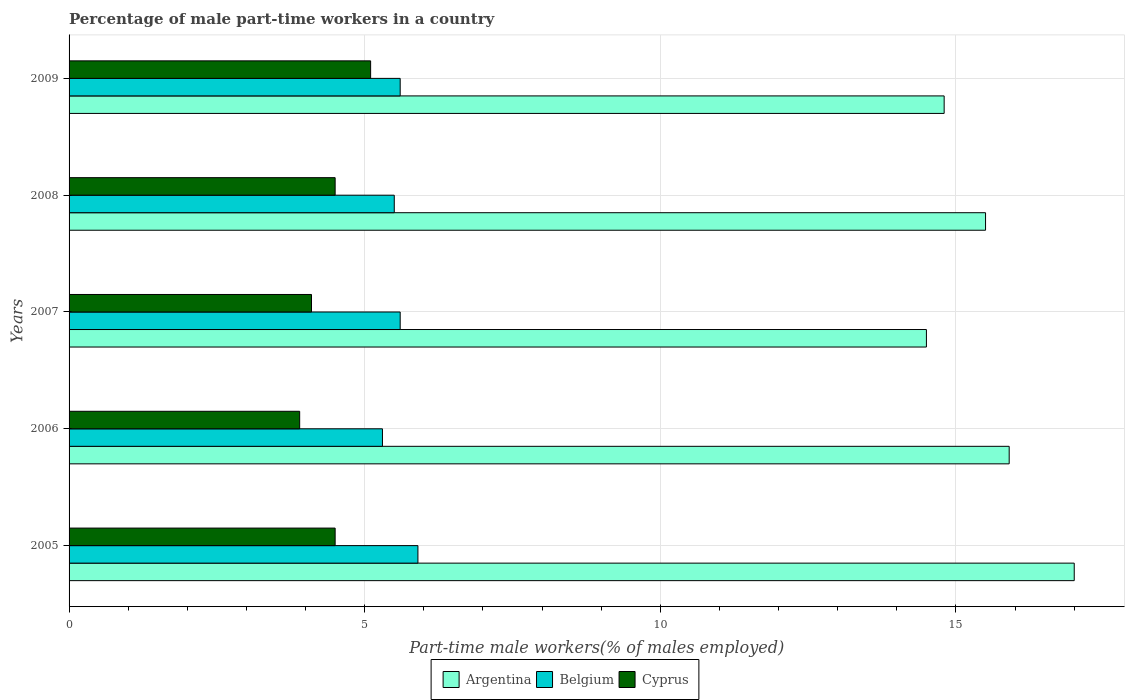How many groups of bars are there?
Keep it short and to the point. 5. Are the number of bars per tick equal to the number of legend labels?
Give a very brief answer. Yes. Are the number of bars on each tick of the Y-axis equal?
Provide a short and direct response. Yes. How many bars are there on the 1st tick from the bottom?
Your response must be concise. 3. What is the label of the 4th group of bars from the top?
Keep it short and to the point. 2006. In how many cases, is the number of bars for a given year not equal to the number of legend labels?
Your response must be concise. 0. What is the percentage of male part-time workers in Belgium in 2008?
Offer a terse response. 5.5. Across all years, what is the maximum percentage of male part-time workers in Belgium?
Provide a short and direct response. 5.9. Across all years, what is the minimum percentage of male part-time workers in Cyprus?
Keep it short and to the point. 3.9. What is the total percentage of male part-time workers in Belgium in the graph?
Your answer should be very brief. 27.9. What is the difference between the percentage of male part-time workers in Belgium in 2006 and that in 2008?
Make the answer very short. -0.2. What is the difference between the percentage of male part-time workers in Cyprus in 2006 and the percentage of male part-time workers in Belgium in 2008?
Your answer should be compact. -1.6. What is the average percentage of male part-time workers in Cyprus per year?
Provide a succinct answer. 4.42. In the year 2005, what is the difference between the percentage of male part-time workers in Belgium and percentage of male part-time workers in Argentina?
Your answer should be compact. -11.1. In how many years, is the percentage of male part-time workers in Argentina greater than 4 %?
Give a very brief answer. 5. What is the ratio of the percentage of male part-time workers in Belgium in 2006 to that in 2008?
Your response must be concise. 0.96. Is the difference between the percentage of male part-time workers in Belgium in 2008 and 2009 greater than the difference between the percentage of male part-time workers in Argentina in 2008 and 2009?
Ensure brevity in your answer.  No. What is the difference between the highest and the second highest percentage of male part-time workers in Cyprus?
Provide a succinct answer. 0.6. What is the difference between the highest and the lowest percentage of male part-time workers in Belgium?
Ensure brevity in your answer.  0.6. Is the sum of the percentage of male part-time workers in Cyprus in 2006 and 2008 greater than the maximum percentage of male part-time workers in Argentina across all years?
Offer a very short reply. No. What does the 3rd bar from the top in 2007 represents?
Offer a very short reply. Argentina. What does the 2nd bar from the bottom in 2005 represents?
Offer a terse response. Belgium. Is it the case that in every year, the sum of the percentage of male part-time workers in Belgium and percentage of male part-time workers in Argentina is greater than the percentage of male part-time workers in Cyprus?
Provide a succinct answer. Yes. How many bars are there?
Keep it short and to the point. 15. Are all the bars in the graph horizontal?
Give a very brief answer. Yes. Are the values on the major ticks of X-axis written in scientific E-notation?
Keep it short and to the point. No. Does the graph contain grids?
Provide a short and direct response. Yes. How many legend labels are there?
Provide a short and direct response. 3. What is the title of the graph?
Your answer should be compact. Percentage of male part-time workers in a country. Does "Syrian Arab Republic" appear as one of the legend labels in the graph?
Make the answer very short. No. What is the label or title of the X-axis?
Offer a very short reply. Part-time male workers(% of males employed). What is the label or title of the Y-axis?
Provide a short and direct response. Years. What is the Part-time male workers(% of males employed) in Argentina in 2005?
Ensure brevity in your answer.  17. What is the Part-time male workers(% of males employed) of Belgium in 2005?
Give a very brief answer. 5.9. What is the Part-time male workers(% of males employed) of Argentina in 2006?
Ensure brevity in your answer.  15.9. What is the Part-time male workers(% of males employed) of Belgium in 2006?
Your answer should be compact. 5.3. What is the Part-time male workers(% of males employed) in Cyprus in 2006?
Keep it short and to the point. 3.9. What is the Part-time male workers(% of males employed) of Argentina in 2007?
Provide a short and direct response. 14.5. What is the Part-time male workers(% of males employed) in Belgium in 2007?
Keep it short and to the point. 5.6. What is the Part-time male workers(% of males employed) of Cyprus in 2007?
Your response must be concise. 4.1. What is the Part-time male workers(% of males employed) in Argentina in 2009?
Offer a very short reply. 14.8. What is the Part-time male workers(% of males employed) of Belgium in 2009?
Provide a short and direct response. 5.6. What is the Part-time male workers(% of males employed) in Cyprus in 2009?
Your answer should be very brief. 5.1. Across all years, what is the maximum Part-time male workers(% of males employed) in Argentina?
Your answer should be compact. 17. Across all years, what is the maximum Part-time male workers(% of males employed) in Belgium?
Your answer should be compact. 5.9. Across all years, what is the maximum Part-time male workers(% of males employed) in Cyprus?
Ensure brevity in your answer.  5.1. Across all years, what is the minimum Part-time male workers(% of males employed) in Belgium?
Offer a terse response. 5.3. Across all years, what is the minimum Part-time male workers(% of males employed) in Cyprus?
Your answer should be very brief. 3.9. What is the total Part-time male workers(% of males employed) of Argentina in the graph?
Ensure brevity in your answer.  77.7. What is the total Part-time male workers(% of males employed) in Belgium in the graph?
Your answer should be very brief. 27.9. What is the total Part-time male workers(% of males employed) of Cyprus in the graph?
Offer a terse response. 22.1. What is the difference between the Part-time male workers(% of males employed) in Belgium in 2005 and that in 2007?
Offer a terse response. 0.3. What is the difference between the Part-time male workers(% of males employed) in Cyprus in 2005 and that in 2007?
Offer a very short reply. 0.4. What is the difference between the Part-time male workers(% of males employed) in Cyprus in 2005 and that in 2008?
Your response must be concise. 0. What is the difference between the Part-time male workers(% of males employed) in Cyprus in 2005 and that in 2009?
Keep it short and to the point. -0.6. What is the difference between the Part-time male workers(% of males employed) in Argentina in 2006 and that in 2007?
Your response must be concise. 1.4. What is the difference between the Part-time male workers(% of males employed) in Belgium in 2006 and that in 2007?
Keep it short and to the point. -0.3. What is the difference between the Part-time male workers(% of males employed) in Cyprus in 2006 and that in 2007?
Offer a very short reply. -0.2. What is the difference between the Part-time male workers(% of males employed) in Argentina in 2006 and that in 2009?
Your response must be concise. 1.1. What is the difference between the Part-time male workers(% of males employed) of Belgium in 2006 and that in 2009?
Make the answer very short. -0.3. What is the difference between the Part-time male workers(% of males employed) of Argentina in 2007 and that in 2008?
Give a very brief answer. -1. What is the difference between the Part-time male workers(% of males employed) in Belgium in 2007 and that in 2008?
Your answer should be very brief. 0.1. What is the difference between the Part-time male workers(% of males employed) of Cyprus in 2007 and that in 2008?
Provide a succinct answer. -0.4. What is the difference between the Part-time male workers(% of males employed) in Argentina in 2007 and that in 2009?
Make the answer very short. -0.3. What is the difference between the Part-time male workers(% of males employed) in Belgium in 2007 and that in 2009?
Ensure brevity in your answer.  0. What is the difference between the Part-time male workers(% of males employed) in Cyprus in 2007 and that in 2009?
Keep it short and to the point. -1. What is the difference between the Part-time male workers(% of males employed) of Argentina in 2008 and that in 2009?
Give a very brief answer. 0.7. What is the difference between the Part-time male workers(% of males employed) of Argentina in 2005 and the Part-time male workers(% of males employed) of Belgium in 2006?
Make the answer very short. 11.7. What is the difference between the Part-time male workers(% of males employed) of Belgium in 2005 and the Part-time male workers(% of males employed) of Cyprus in 2006?
Ensure brevity in your answer.  2. What is the difference between the Part-time male workers(% of males employed) of Argentina in 2005 and the Part-time male workers(% of males employed) of Belgium in 2007?
Keep it short and to the point. 11.4. What is the difference between the Part-time male workers(% of males employed) in Argentina in 2005 and the Part-time male workers(% of males employed) in Belgium in 2008?
Your response must be concise. 11.5. What is the difference between the Part-time male workers(% of males employed) of Argentina in 2005 and the Part-time male workers(% of males employed) of Cyprus in 2008?
Your response must be concise. 12.5. What is the difference between the Part-time male workers(% of males employed) in Argentina in 2005 and the Part-time male workers(% of males employed) in Belgium in 2009?
Ensure brevity in your answer.  11.4. What is the difference between the Part-time male workers(% of males employed) of Belgium in 2005 and the Part-time male workers(% of males employed) of Cyprus in 2009?
Your answer should be very brief. 0.8. What is the difference between the Part-time male workers(% of males employed) in Argentina in 2006 and the Part-time male workers(% of males employed) in Belgium in 2007?
Offer a very short reply. 10.3. What is the difference between the Part-time male workers(% of males employed) in Argentina in 2006 and the Part-time male workers(% of males employed) in Cyprus in 2007?
Make the answer very short. 11.8. What is the difference between the Part-time male workers(% of males employed) of Belgium in 2006 and the Part-time male workers(% of males employed) of Cyprus in 2007?
Offer a terse response. 1.2. What is the difference between the Part-time male workers(% of males employed) in Argentina in 2006 and the Part-time male workers(% of males employed) in Belgium in 2008?
Offer a terse response. 10.4. What is the difference between the Part-time male workers(% of males employed) in Argentina in 2006 and the Part-time male workers(% of males employed) in Belgium in 2009?
Ensure brevity in your answer.  10.3. What is the difference between the Part-time male workers(% of males employed) of Argentina in 2006 and the Part-time male workers(% of males employed) of Cyprus in 2009?
Your answer should be very brief. 10.8. What is the difference between the Part-time male workers(% of males employed) in Argentina in 2007 and the Part-time male workers(% of males employed) in Belgium in 2008?
Your answer should be compact. 9. What is the difference between the Part-time male workers(% of males employed) of Belgium in 2007 and the Part-time male workers(% of males employed) of Cyprus in 2008?
Provide a succinct answer. 1.1. What is the difference between the Part-time male workers(% of males employed) of Argentina in 2007 and the Part-time male workers(% of males employed) of Belgium in 2009?
Ensure brevity in your answer.  8.9. What is the difference between the Part-time male workers(% of males employed) of Argentina in 2008 and the Part-time male workers(% of males employed) of Cyprus in 2009?
Provide a succinct answer. 10.4. What is the difference between the Part-time male workers(% of males employed) in Belgium in 2008 and the Part-time male workers(% of males employed) in Cyprus in 2009?
Ensure brevity in your answer.  0.4. What is the average Part-time male workers(% of males employed) in Argentina per year?
Ensure brevity in your answer.  15.54. What is the average Part-time male workers(% of males employed) in Belgium per year?
Offer a very short reply. 5.58. What is the average Part-time male workers(% of males employed) in Cyprus per year?
Your answer should be very brief. 4.42. In the year 2005, what is the difference between the Part-time male workers(% of males employed) in Argentina and Part-time male workers(% of males employed) in Belgium?
Keep it short and to the point. 11.1. In the year 2006, what is the difference between the Part-time male workers(% of males employed) of Argentina and Part-time male workers(% of males employed) of Belgium?
Ensure brevity in your answer.  10.6. In the year 2006, what is the difference between the Part-time male workers(% of males employed) of Argentina and Part-time male workers(% of males employed) of Cyprus?
Give a very brief answer. 12. In the year 2007, what is the difference between the Part-time male workers(% of males employed) in Argentina and Part-time male workers(% of males employed) in Belgium?
Provide a succinct answer. 8.9. In the year 2007, what is the difference between the Part-time male workers(% of males employed) in Argentina and Part-time male workers(% of males employed) in Cyprus?
Your response must be concise. 10.4. In the year 2007, what is the difference between the Part-time male workers(% of males employed) in Belgium and Part-time male workers(% of males employed) in Cyprus?
Offer a terse response. 1.5. In the year 2008, what is the difference between the Part-time male workers(% of males employed) of Belgium and Part-time male workers(% of males employed) of Cyprus?
Ensure brevity in your answer.  1. In the year 2009, what is the difference between the Part-time male workers(% of males employed) of Argentina and Part-time male workers(% of males employed) of Cyprus?
Keep it short and to the point. 9.7. What is the ratio of the Part-time male workers(% of males employed) in Argentina in 2005 to that in 2006?
Offer a very short reply. 1.07. What is the ratio of the Part-time male workers(% of males employed) in Belgium in 2005 to that in 2006?
Give a very brief answer. 1.11. What is the ratio of the Part-time male workers(% of males employed) in Cyprus in 2005 to that in 2006?
Offer a terse response. 1.15. What is the ratio of the Part-time male workers(% of males employed) in Argentina in 2005 to that in 2007?
Your response must be concise. 1.17. What is the ratio of the Part-time male workers(% of males employed) in Belgium in 2005 to that in 2007?
Give a very brief answer. 1.05. What is the ratio of the Part-time male workers(% of males employed) of Cyprus in 2005 to that in 2007?
Give a very brief answer. 1.1. What is the ratio of the Part-time male workers(% of males employed) in Argentina in 2005 to that in 2008?
Your answer should be very brief. 1.1. What is the ratio of the Part-time male workers(% of males employed) in Belgium in 2005 to that in 2008?
Offer a very short reply. 1.07. What is the ratio of the Part-time male workers(% of males employed) in Cyprus in 2005 to that in 2008?
Keep it short and to the point. 1. What is the ratio of the Part-time male workers(% of males employed) in Argentina in 2005 to that in 2009?
Your answer should be very brief. 1.15. What is the ratio of the Part-time male workers(% of males employed) of Belgium in 2005 to that in 2009?
Provide a short and direct response. 1.05. What is the ratio of the Part-time male workers(% of males employed) of Cyprus in 2005 to that in 2009?
Keep it short and to the point. 0.88. What is the ratio of the Part-time male workers(% of males employed) in Argentina in 2006 to that in 2007?
Provide a short and direct response. 1.1. What is the ratio of the Part-time male workers(% of males employed) in Belgium in 2006 to that in 2007?
Provide a succinct answer. 0.95. What is the ratio of the Part-time male workers(% of males employed) of Cyprus in 2006 to that in 2007?
Provide a succinct answer. 0.95. What is the ratio of the Part-time male workers(% of males employed) in Argentina in 2006 to that in 2008?
Make the answer very short. 1.03. What is the ratio of the Part-time male workers(% of males employed) of Belgium in 2006 to that in 2008?
Ensure brevity in your answer.  0.96. What is the ratio of the Part-time male workers(% of males employed) of Cyprus in 2006 to that in 2008?
Provide a succinct answer. 0.87. What is the ratio of the Part-time male workers(% of males employed) of Argentina in 2006 to that in 2009?
Keep it short and to the point. 1.07. What is the ratio of the Part-time male workers(% of males employed) in Belgium in 2006 to that in 2009?
Your response must be concise. 0.95. What is the ratio of the Part-time male workers(% of males employed) in Cyprus in 2006 to that in 2009?
Provide a short and direct response. 0.76. What is the ratio of the Part-time male workers(% of males employed) of Argentina in 2007 to that in 2008?
Provide a short and direct response. 0.94. What is the ratio of the Part-time male workers(% of males employed) in Belgium in 2007 to that in 2008?
Provide a short and direct response. 1.02. What is the ratio of the Part-time male workers(% of males employed) of Cyprus in 2007 to that in 2008?
Offer a very short reply. 0.91. What is the ratio of the Part-time male workers(% of males employed) of Argentina in 2007 to that in 2009?
Provide a succinct answer. 0.98. What is the ratio of the Part-time male workers(% of males employed) of Cyprus in 2007 to that in 2009?
Your response must be concise. 0.8. What is the ratio of the Part-time male workers(% of males employed) in Argentina in 2008 to that in 2009?
Make the answer very short. 1.05. What is the ratio of the Part-time male workers(% of males employed) of Belgium in 2008 to that in 2009?
Ensure brevity in your answer.  0.98. What is the ratio of the Part-time male workers(% of males employed) in Cyprus in 2008 to that in 2009?
Keep it short and to the point. 0.88. What is the difference between the highest and the second highest Part-time male workers(% of males employed) of Cyprus?
Give a very brief answer. 0.6. What is the difference between the highest and the lowest Part-time male workers(% of males employed) of Cyprus?
Give a very brief answer. 1.2. 